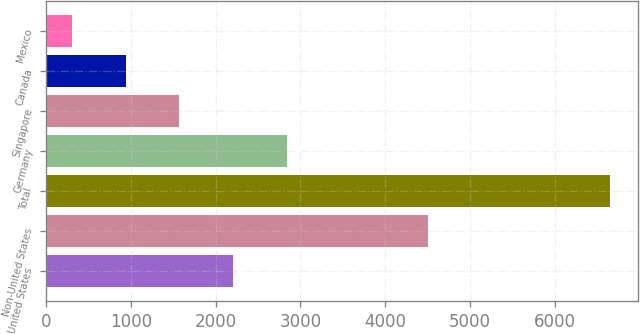Convert chart. <chart><loc_0><loc_0><loc_500><loc_500><bar_chart><fcel>United States<fcel>Non-United States<fcel>Total<fcel>Germany<fcel>Singapore<fcel>Canada<fcel>Mexico<nl><fcel>2208.9<fcel>4508<fcel>6656<fcel>2844.2<fcel>1573.6<fcel>938.3<fcel>303<nl></chart> 